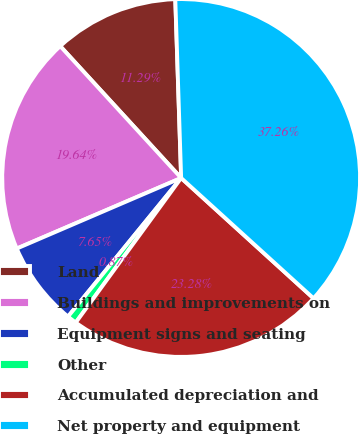Convert chart to OTSL. <chart><loc_0><loc_0><loc_500><loc_500><pie_chart><fcel>Land<fcel>Buildings and improvements on<fcel>Equipment signs and seating<fcel>Other<fcel>Accumulated depreciation and<fcel>Net property and equipment<nl><fcel>11.29%<fcel>19.64%<fcel>7.65%<fcel>0.87%<fcel>23.28%<fcel>37.26%<nl></chart> 